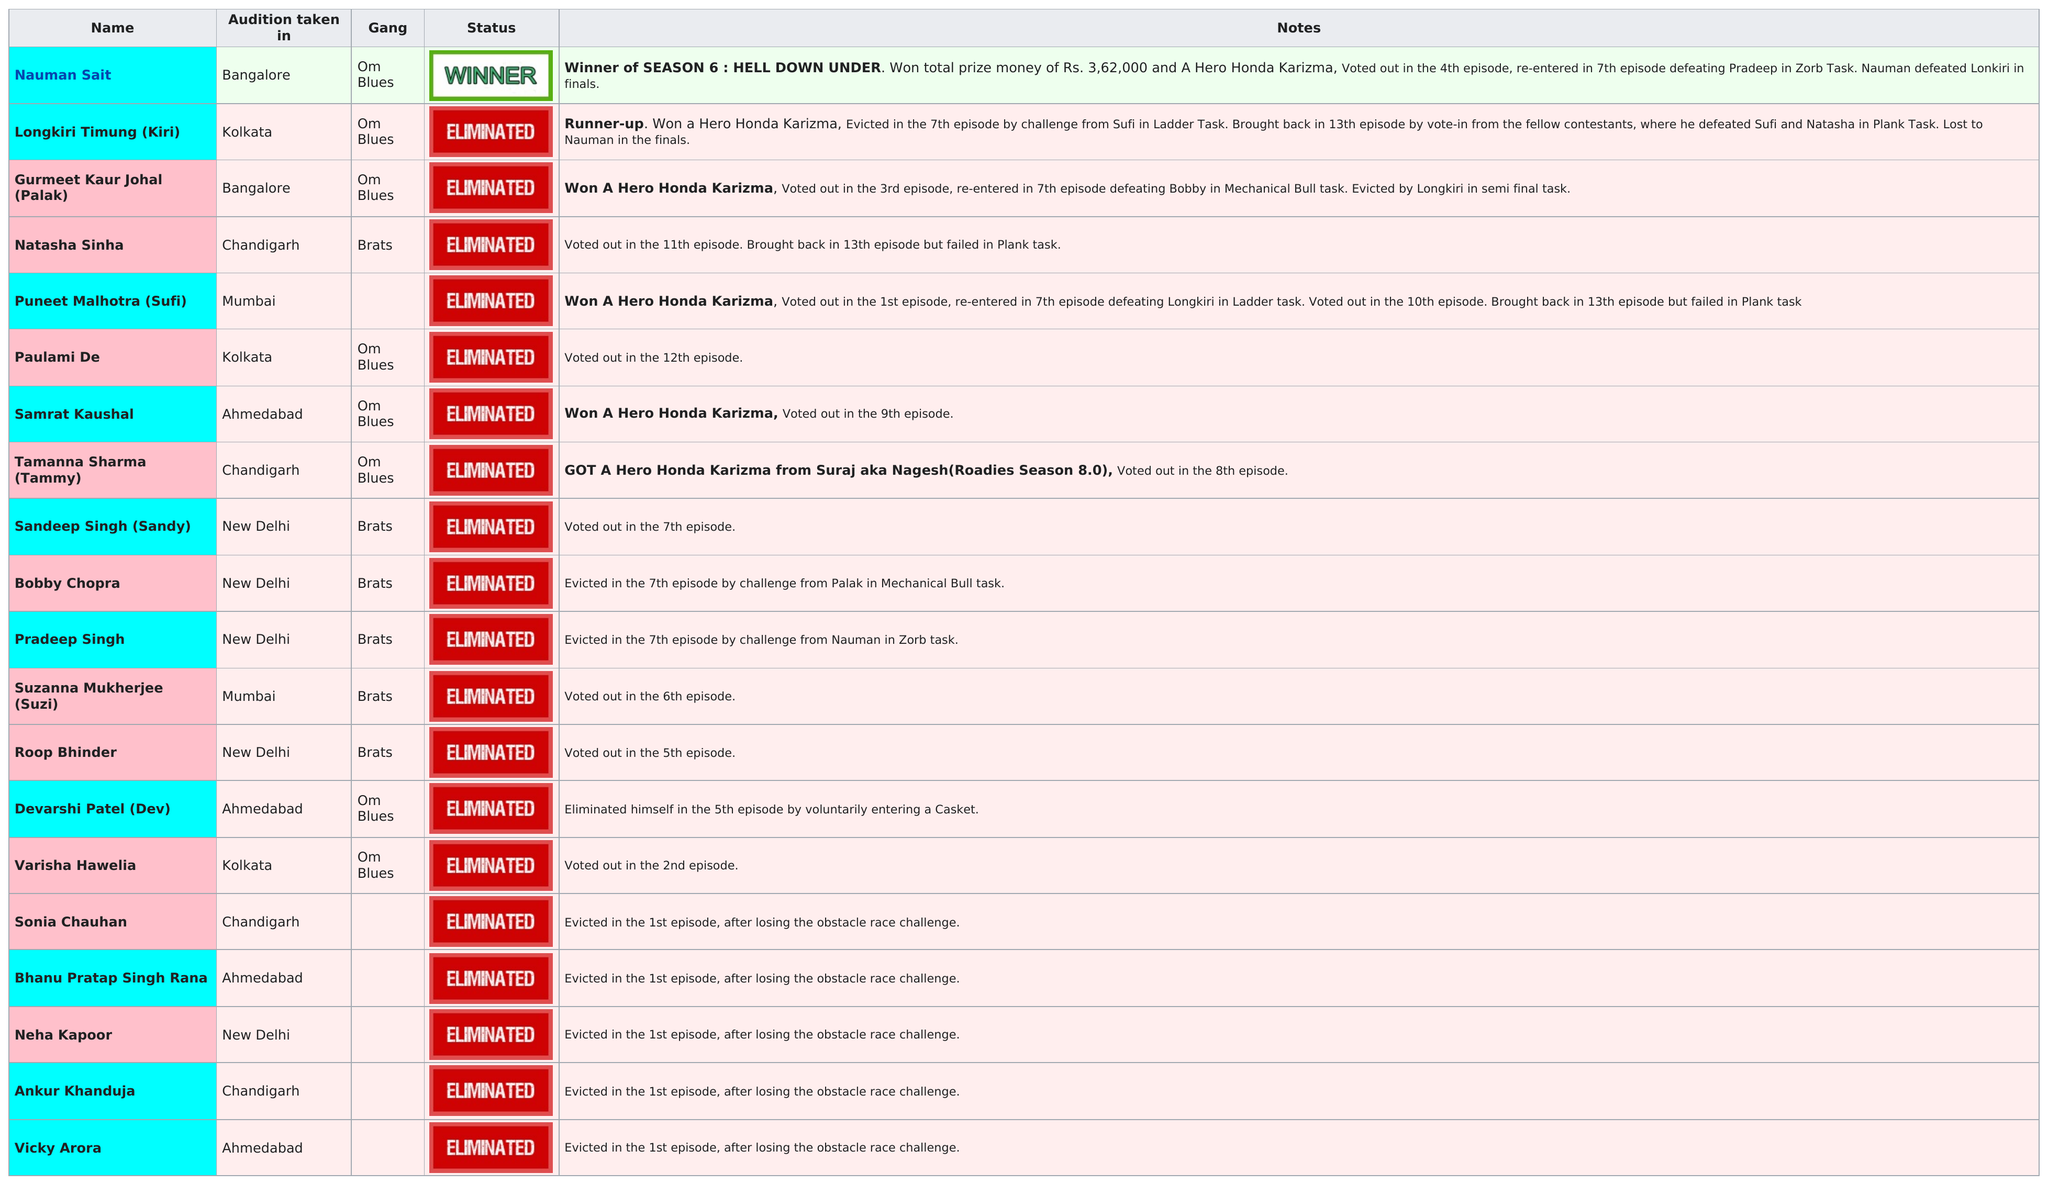Mention a couple of crucial points in this snapshot. MTV Roadies Season 6 featured a gang called Om Blues, who had at least one winner. The gang known as Om Blues had the most eliminations. A total of 19 people were eliminated. In the semi-final task, Palak was eliminated by Longkiri. A total of 20 contestants initially participated in the season. 